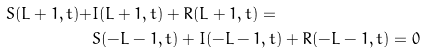Convert formula to latex. <formula><loc_0><loc_0><loc_500><loc_500>S ( L + 1 , t ) + & I ( L + 1 , t ) + R ( L + 1 , t ) = \\ & S ( - L - 1 , t ) + I ( - L - 1 , t ) + R ( - L - 1 , t ) = 0</formula> 